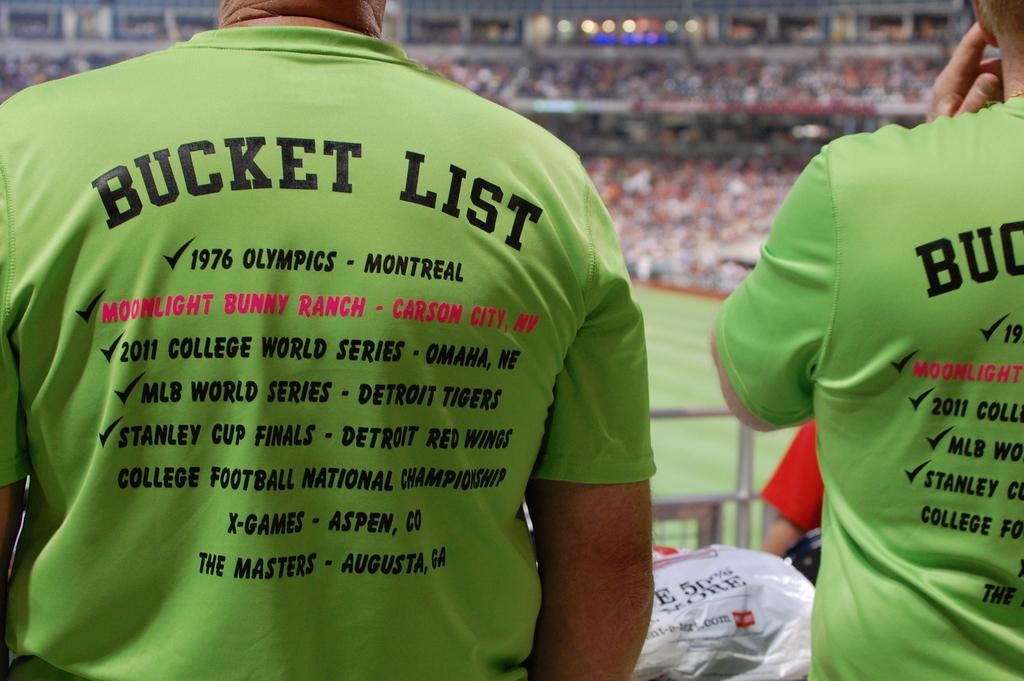<image>
Render a clear and concise summary of the photo. two men are at a baseball game wearing bucket list shirts 